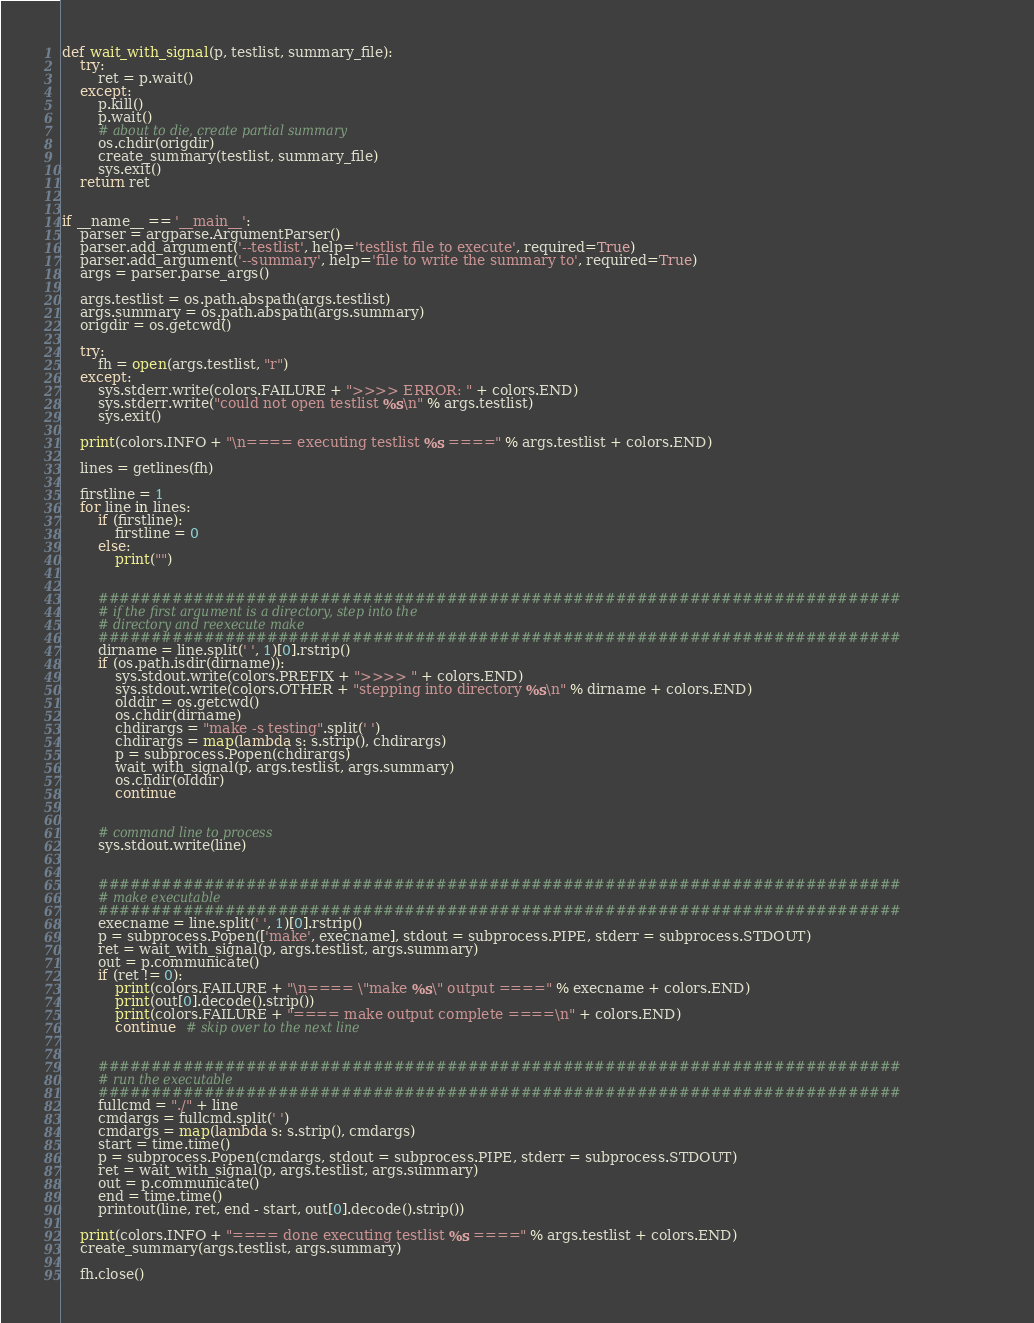<code> <loc_0><loc_0><loc_500><loc_500><_Python_>

def wait_with_signal(p, testlist, summary_file):
    try:
        ret = p.wait()
    except:
        p.kill()
        p.wait()
        # about to die, create partial summary
        os.chdir(origdir)
        create_summary(testlist, summary_file)
        sys.exit()
    return ret


if __name__ == '__main__':
    parser = argparse.ArgumentParser()
    parser.add_argument('--testlist', help='testlist file to execute', required=True)
    parser.add_argument('--summary', help='file to write the summary to', required=True)
    args = parser.parse_args()

    args.testlist = os.path.abspath(args.testlist)
    args.summary = os.path.abspath(args.summary)
    origdir = os.getcwd()

    try:
        fh = open(args.testlist, "r")
    except:
        sys.stderr.write(colors.FAILURE + ">>>> ERROR: " + colors.END)
        sys.stderr.write("could not open testlist %s\n" % args.testlist)
        sys.exit()

    print(colors.INFO + "\n==== executing testlist %s ====" % args.testlist + colors.END)

    lines = getlines(fh)

    firstline = 1
    for line in lines:
        if (firstline):
            firstline = 0
        else:
            print("")


        ############################################################################
        # if the first argument is a directory, step into the
        # directory and reexecute make
        ############################################################################
        dirname = line.split(' ', 1)[0].rstrip()
        if (os.path.isdir(dirname)):
            sys.stdout.write(colors.PREFIX + ">>>> " + colors.END)
            sys.stdout.write(colors.OTHER + "stepping into directory %s\n" % dirname + colors.END)
            olddir = os.getcwd()
            os.chdir(dirname)
            chdirargs = "make -s testing".split(' ')
            chdirargs = map(lambda s: s.strip(), chdirargs)
            p = subprocess.Popen(chdirargs)
            wait_with_signal(p, args.testlist, args.summary)
            os.chdir(olddir)
            continue


        # command line to process
        sys.stdout.write(line)


        ############################################################################
        # make executable
        ############################################################################
        execname = line.split(' ', 1)[0].rstrip()
        p = subprocess.Popen(['make', execname], stdout = subprocess.PIPE, stderr = subprocess.STDOUT)
        ret = wait_with_signal(p, args.testlist, args.summary)
        out = p.communicate()
        if (ret != 0):
            print(colors.FAILURE + "\n==== \"make %s\" output ====" % execname + colors.END)
            print(out[0].decode().strip())
            print(colors.FAILURE + "==== make output complete ====\n" + colors.END)
            continue  # skip over to the next line


        ############################################################################
        # run the executable
        ############################################################################
        fullcmd = "./" + line
        cmdargs = fullcmd.split(' ')
        cmdargs = map(lambda s: s.strip(), cmdargs)
        start = time.time()
        p = subprocess.Popen(cmdargs, stdout = subprocess.PIPE, stderr = subprocess.STDOUT)
        ret = wait_with_signal(p, args.testlist, args.summary)
        out = p.communicate()
        end = time.time()
        printout(line, ret, end - start, out[0].decode().strip())

    print(colors.INFO + "==== done executing testlist %s ====" % args.testlist + colors.END)
    create_summary(args.testlist, args.summary)

    fh.close()
</code> 